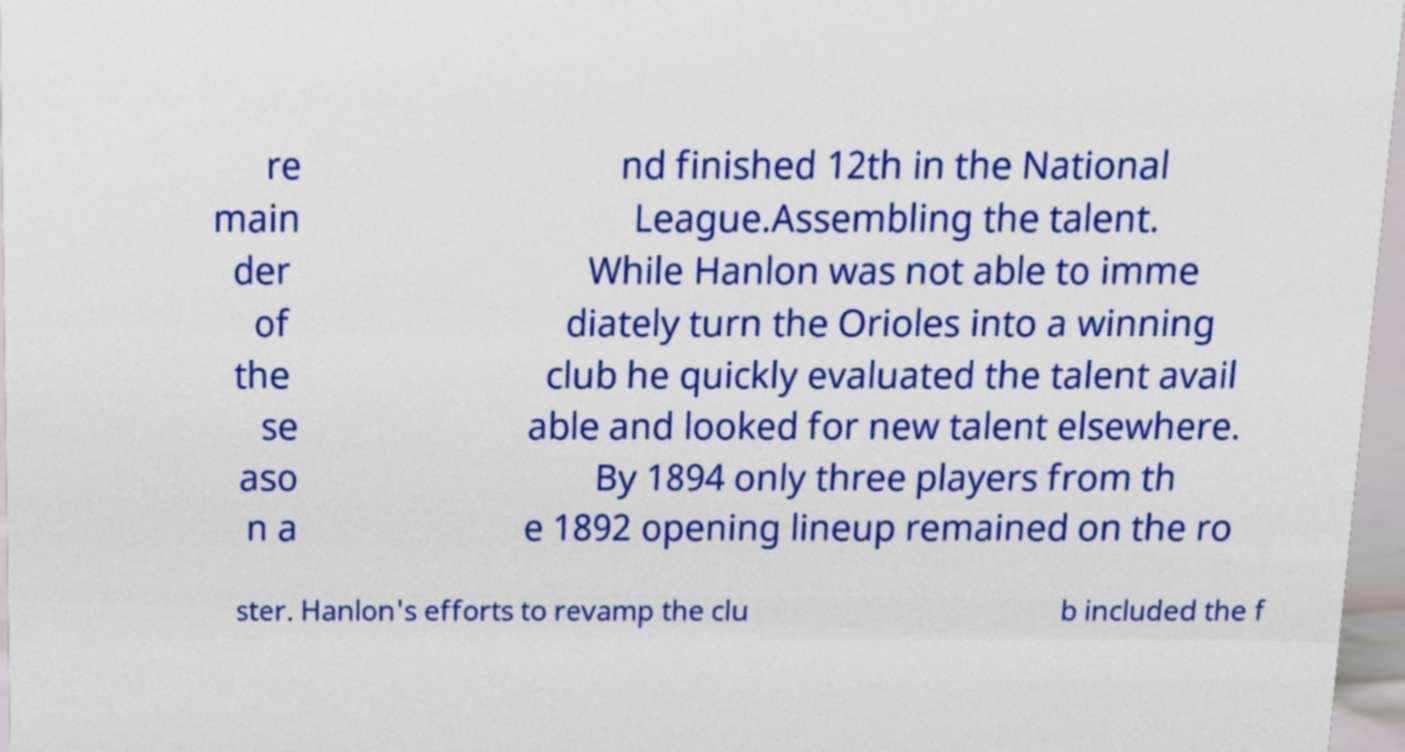For documentation purposes, I need the text within this image transcribed. Could you provide that? re main der of the se aso n a nd finished 12th in the National League.Assembling the talent. While Hanlon was not able to imme diately turn the Orioles into a winning club he quickly evaluated the talent avail able and looked for new talent elsewhere. By 1894 only three players from th e 1892 opening lineup remained on the ro ster. Hanlon's efforts to revamp the clu b included the f 